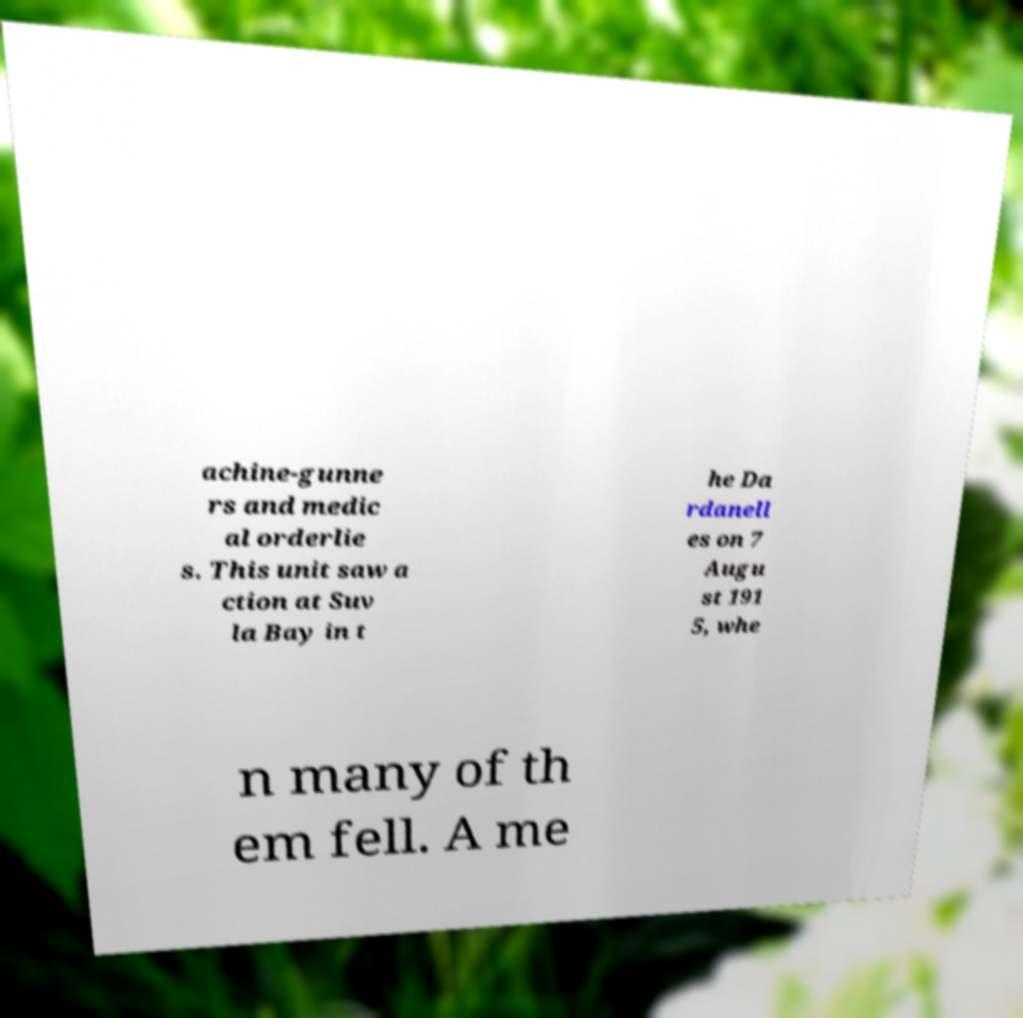For documentation purposes, I need the text within this image transcribed. Could you provide that? achine-gunne rs and medic al orderlie s. This unit saw a ction at Suv la Bay in t he Da rdanell es on 7 Augu st 191 5, whe n many of th em fell. A me 